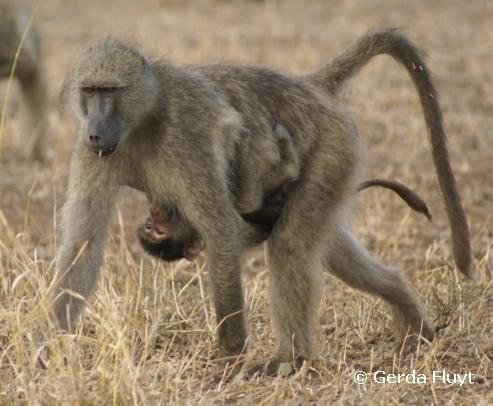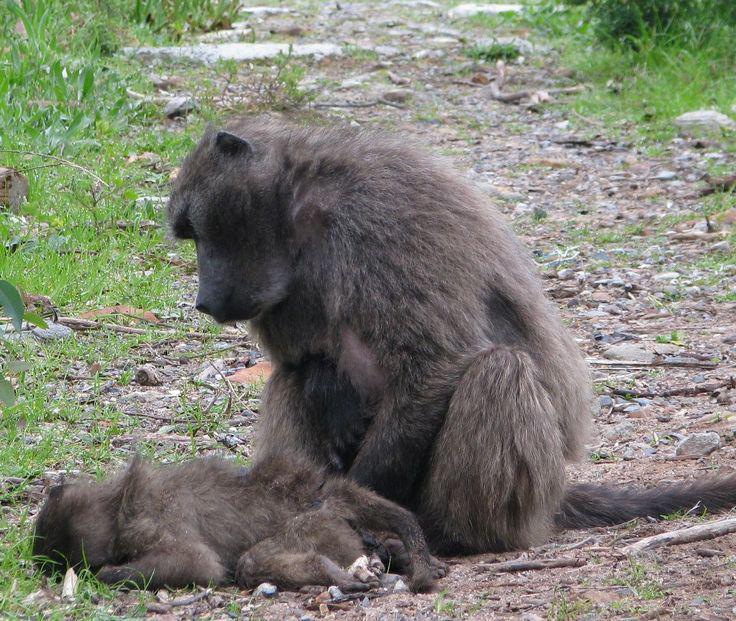The first image is the image on the left, the second image is the image on the right. Assess this claim about the two images: "A baboon is carrying its young in one of the images.". Correct or not? Answer yes or no. Yes. The first image is the image on the left, the second image is the image on the right. Examine the images to the left and right. Is the description "In one image, two baboons are fighting, at least one with fangs bared, and the tail of the monkey on the left is extended with a bend in it." accurate? Answer yes or no. No. 